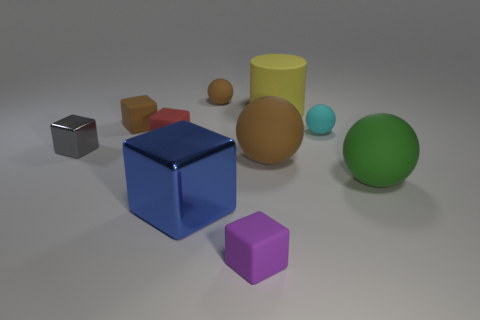Subtract 1 spheres. How many spheres are left? 3 Subtract all red cubes. How many cubes are left? 4 Subtract all large shiny cubes. How many cubes are left? 4 Subtract all yellow blocks. Subtract all brown balls. How many blocks are left? 5 Subtract all balls. How many objects are left? 6 Subtract all small green cylinders. Subtract all big blue cubes. How many objects are left? 9 Add 3 large blocks. How many large blocks are left? 4 Add 2 purple things. How many purple things exist? 3 Subtract 1 gray cubes. How many objects are left? 9 